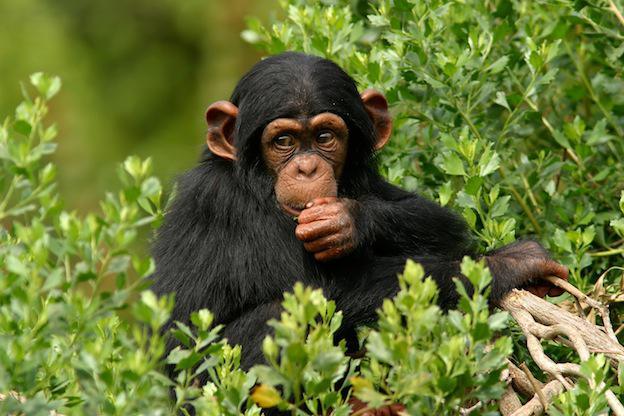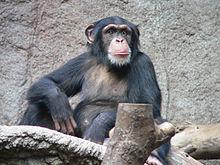The first image is the image on the left, the second image is the image on the right. Considering the images on both sides, is "The image on the right shows a single animal gazing into the distance." valid? Answer yes or no. Yes. The first image is the image on the left, the second image is the image on the right. Given the left and right images, does the statement "The left photo contains a single chimp." hold true? Answer yes or no. Yes. 